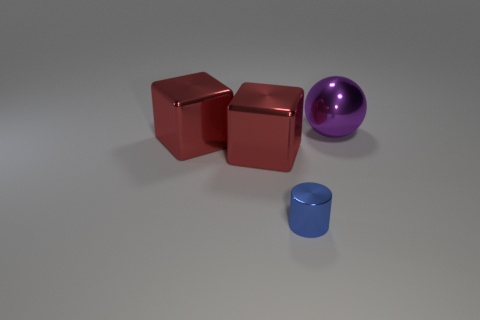How many small red rubber objects are there?
Offer a terse response. 0. There is a large thing right of the blue shiny cylinder; are there any small objects that are left of it?
Your response must be concise. Yes. How many objects are either blue cylinders that are in front of the purple ball or large purple shiny balls?
Ensure brevity in your answer.  2. Is the number of objects that are right of the small blue cylinder greater than the number of small blue cylinders that are behind the ball?
Ensure brevity in your answer.  Yes. How many cubes are either tiny blue metal objects or purple shiny things?
Give a very brief answer. 0. Are there more small blue shiny objects than red blocks?
Offer a very short reply. No. How many objects are large brown metallic blocks or large purple spheres?
Keep it short and to the point. 1. Are there any other things that are the same size as the shiny cylinder?
Offer a very short reply. No. Is the number of blue metallic objects that are to the left of the cylinder less than the number of large objects that are left of the big ball?
Give a very brief answer. Yes. How many other things are there of the same shape as the purple shiny object?
Make the answer very short. 0. 